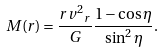Convert formula to latex. <formula><loc_0><loc_0><loc_500><loc_500>M ( r ) = \frac { r { v ^ { 2 } } _ { r } } { G } \frac { 1 - \cos { \eta } } { \sin ^ { 2 } \eta } .</formula> 